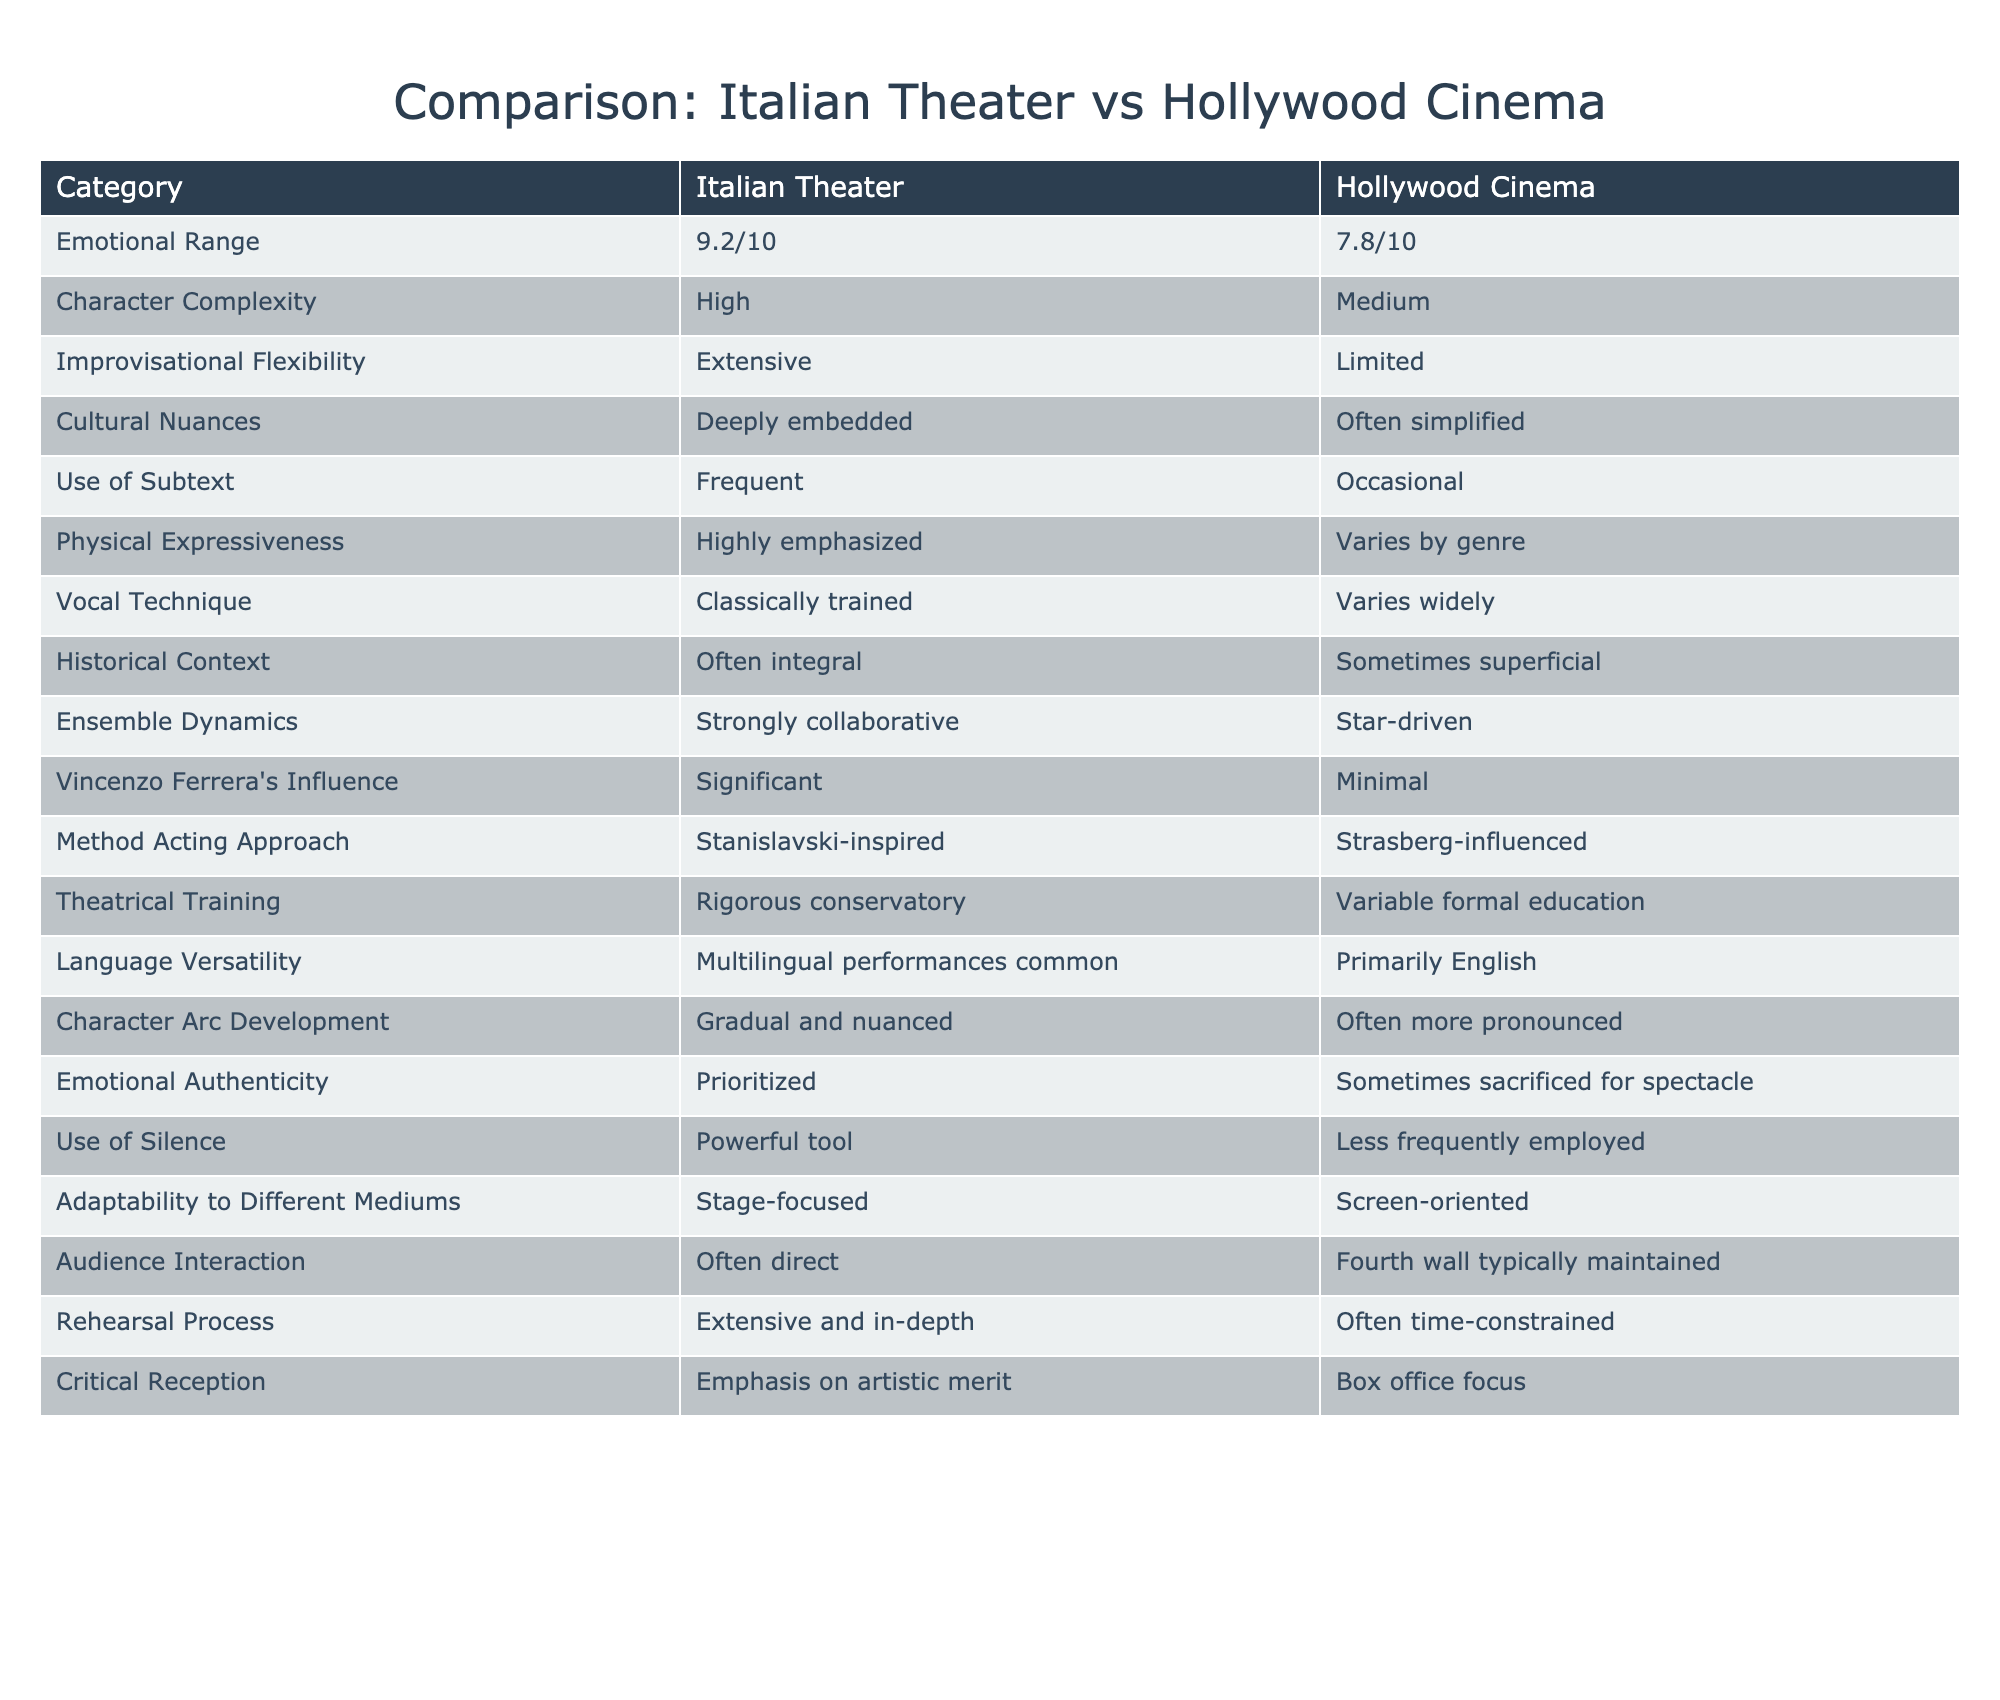What is the emotional range score for Italian theater? The table indicates that the emotional range for Italian theater is rated at 9.2 out of 10.
Answer: 9.2/10 How does the character complexity in Italian theater compare to Hollywood cinema? The table shows that Italian theater has high character complexity, while Hollywood cinema has medium complexity.
Answer: High vs. Medium Is improvisational flexibility more extensive in Italian theater than in Hollywood cinema? According to the table, Italian theater has extensive improvisational flexibility, while Hollywood cinema is described as limited, confirming that it is indeed more extensive.
Answer: Yes What is the difference in the emotional range scores between Italian theater and Hollywood cinema? The emotional range scores show Italian theater at 9.2 and Hollywood cinema at 7.8. The difference is 9.2 - 7.8 = 1.4.
Answer: 1.4 Does Italian theater prioritize emotional authenticity more than Hollywood cinema? The table indicates that emotional authenticity is prioritized in Italian theater but is sometimes sacrificed for spectacle in Hollywood cinema, making this statement true.
Answer: Yes What are the primary language performance differences mentioned between Italian theater and Hollywood cinema? The table notes that multilingual performances are common in Italian theater, whereas Hollywood cinema primarily uses English.
Answer: Multilingual vs. Primarily English Which theatrical aspect has a stronger presence in Italian theater: use of silence or vocal technique? The table emphasizes that the use of silence is a powerful tool in Italian theater, while vocal technique varies widely. Therefore, use of silence has a stronger presence.
Answer: Use of silence How many categories indicate that Italian theater uses a more collaborative approach than Hollywood cinema? From the table, categories that reflect collaborative aspects include ensemble dynamics (strongly collaborative) and improvisational flexibility (extensive). Thus, there are two categories.
Answer: 2 In terms of historical context, is it more integral to Italian theater or occasionally superficial in Hollywood cinema? The table clearly states that historical context is often integral to Italian theater while being sometimes superficial in Hollywood cinema, confirming the assertion.
Answer: More integral to Italian theater 